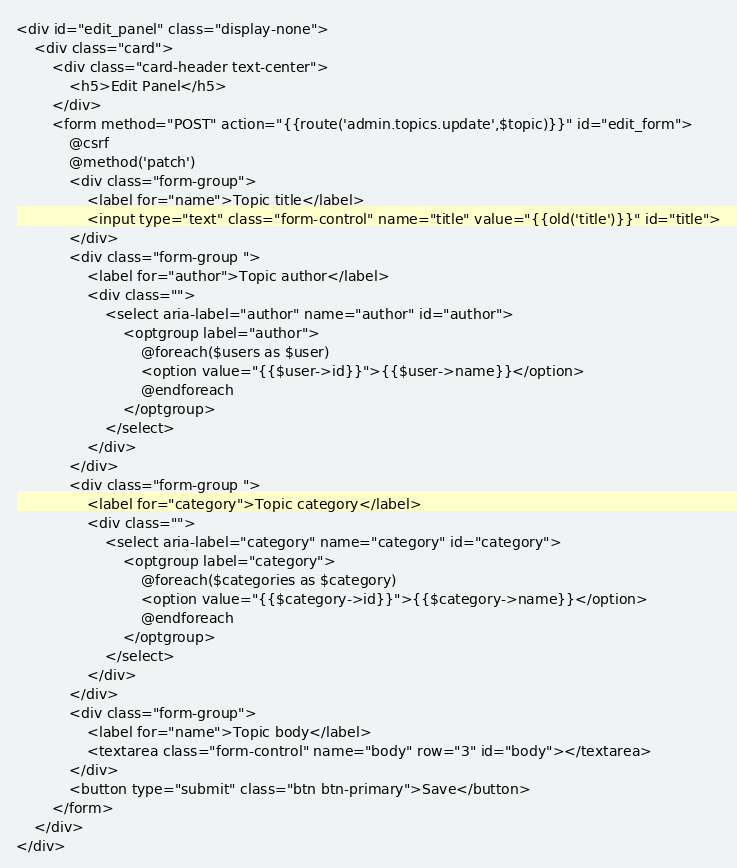<code> <loc_0><loc_0><loc_500><loc_500><_PHP_><div id="edit_panel" class="display-none">
    <div class="card">
        <div class="card-header text-center">
            <h5>Edit Panel</h5>
        </div>
        <form method="POST" action="{{route('admin.topics.update',$topic)}}" id="edit_form">
            @csrf
            @method('patch')
            <div class="form-group">
                <label for="name">Topic title</label>
                <input type="text" class="form-control" name="title" value="{{old('title')}}" id="title">
            </div>
            <div class="form-group ">
                <label for="author">Topic author</label>
                <div class="">
                    <select aria-label="author" name="author" id="author">
                        <optgroup label="author">
                            @foreach($users as $user)
                            <option value="{{$user->id}}">{{$user->name}}</option>
                            @endforeach
                        </optgroup>
                    </select>
                </div>
            </div>
            <div class="form-group ">
                <label for="category">Topic category</label>
                <div class="">
                    <select aria-label="category" name="category" id="category">
                        <optgroup label="category">
                            @foreach($categories as $category)
                            <option value="{{$category->id}}">{{$category->name}}</option>
                            @endforeach
                        </optgroup>
                    </select>
                </div>
            </div>
            <div class="form-group">
                <label for="name">Topic body</label>
                <textarea class="form-control" name="body" row="3" id="body"></textarea>
            </div>
            <button type="submit" class="btn btn-primary">Save</button>
        </form>
    </div>
</div></code> 